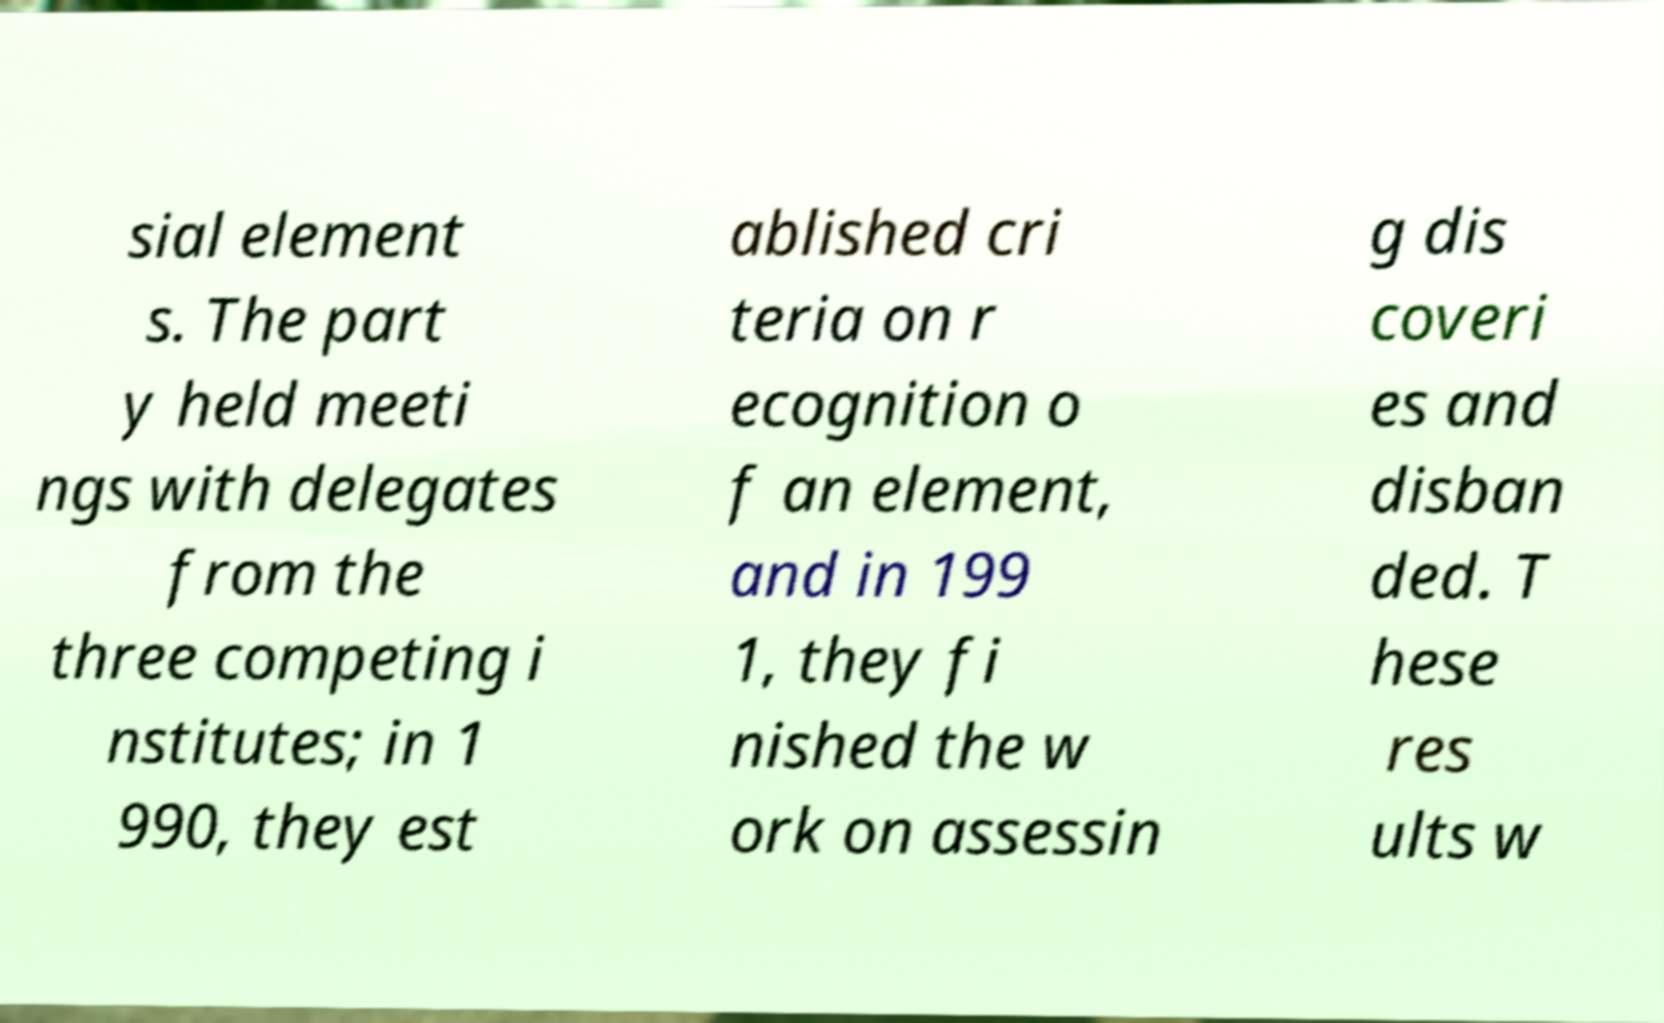Could you assist in decoding the text presented in this image and type it out clearly? sial element s. The part y held meeti ngs with delegates from the three competing i nstitutes; in 1 990, they est ablished cri teria on r ecognition o f an element, and in 199 1, they fi nished the w ork on assessin g dis coveri es and disban ded. T hese res ults w 